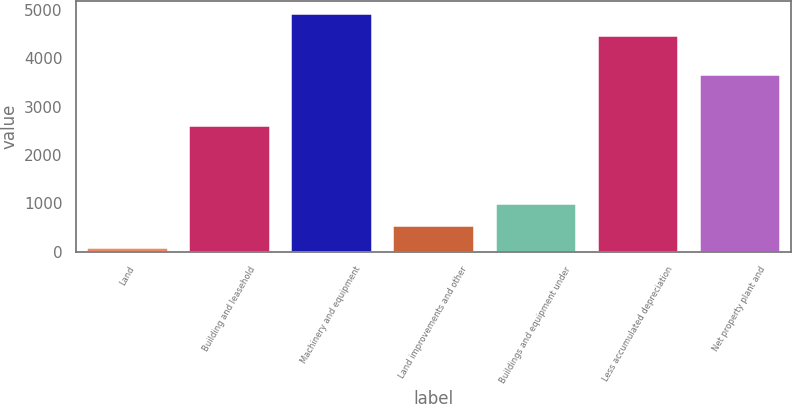Convert chart to OTSL. <chart><loc_0><loc_0><loc_500><loc_500><bar_chart><fcel>Land<fcel>Building and leasehold<fcel>Machinery and equipment<fcel>Land improvements and other<fcel>Buildings and equipment under<fcel>Less accumulated depreciation<fcel>Net property plant and<nl><fcel>97<fcel>2617<fcel>4938.7<fcel>556.7<fcel>1016.4<fcel>4479<fcel>3674<nl></chart> 